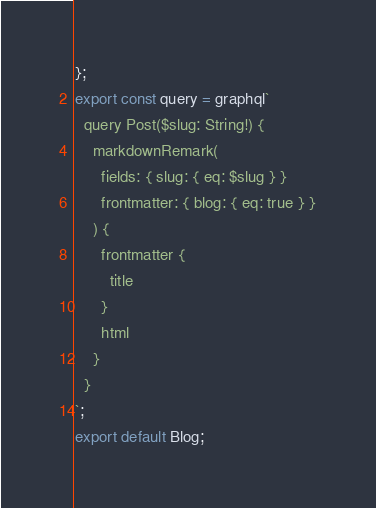<code> <loc_0><loc_0><loc_500><loc_500><_JavaScript_>};
export const query = graphql`
  query Post($slug: String!) {
    markdownRemark(
      fields: { slug: { eq: $slug } }
      frontmatter: { blog: { eq: true } }
    ) {
      frontmatter {
        title
      }
      html
    }
  }
`;
export default Blog;
</code> 